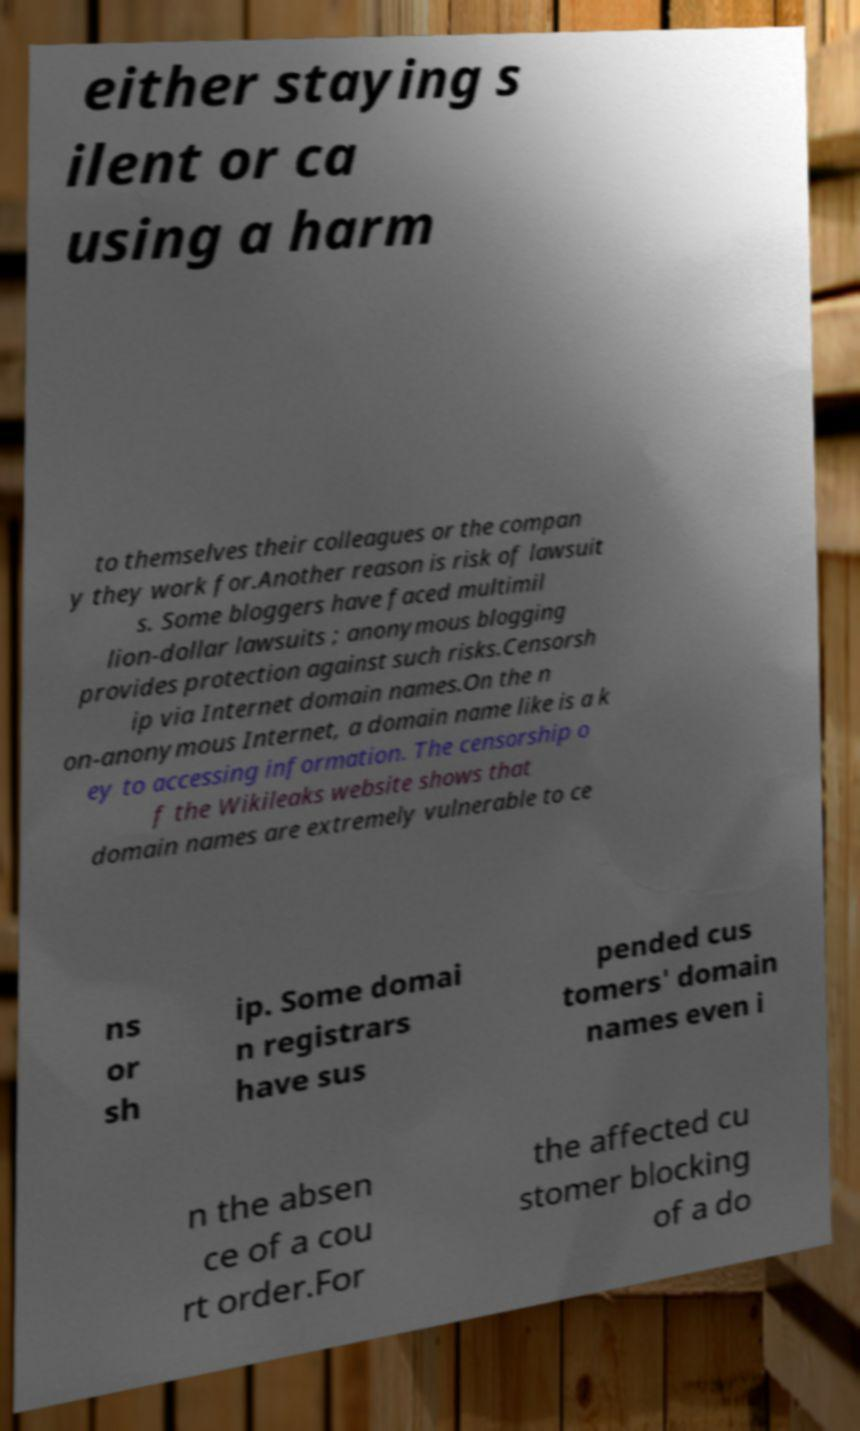There's text embedded in this image that I need extracted. Can you transcribe it verbatim? either staying s ilent or ca using a harm to themselves their colleagues or the compan y they work for.Another reason is risk of lawsuit s. Some bloggers have faced multimil lion-dollar lawsuits ; anonymous blogging provides protection against such risks.Censorsh ip via Internet domain names.On the n on-anonymous Internet, a domain name like is a k ey to accessing information. The censorship o f the Wikileaks website shows that domain names are extremely vulnerable to ce ns or sh ip. Some domai n registrars have sus pended cus tomers' domain names even i n the absen ce of a cou rt order.For the affected cu stomer blocking of a do 